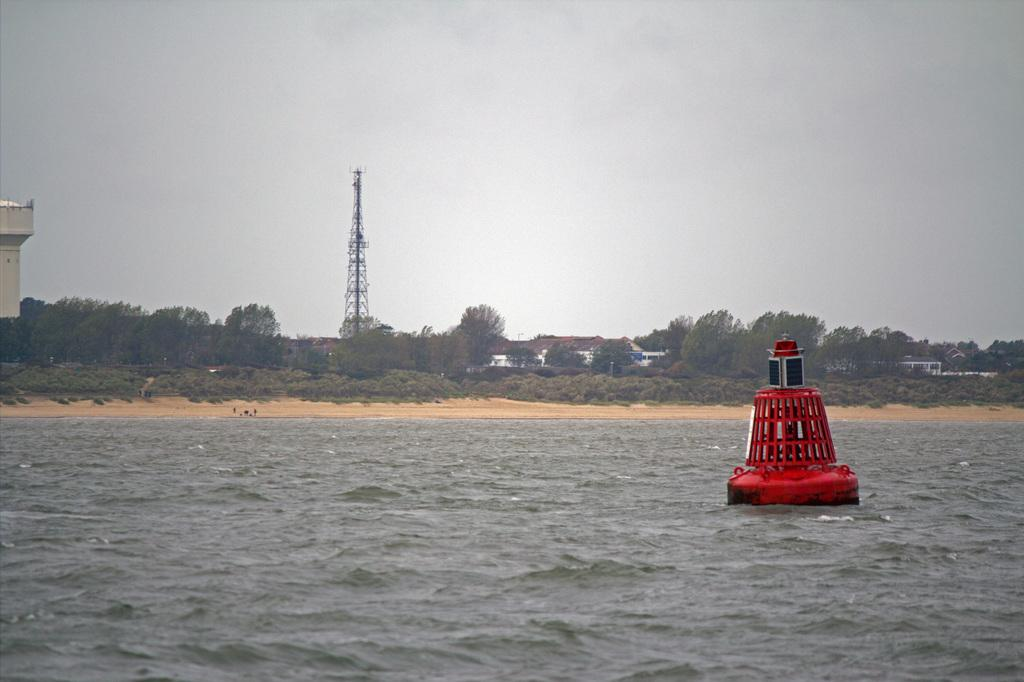What type of structures can be seen in the image? There are houses in the image. What natural elements are present in the image? There are trees in the image. What architectural feature is visible in the image? There is a tower in the image. What man-made object is present in the image? There is a water tank in the image. What is floating on the water surface in the image? There is a red and black color object on the water surface. What is the color of the sky in the image? The sky is blue and white in color. What type of pancake is being served on the canvas in the image? There is no pancake or canvas present in the image. How quiet is the environment in the image? The image does not provide any information about the noise level or quietness of the environment. 